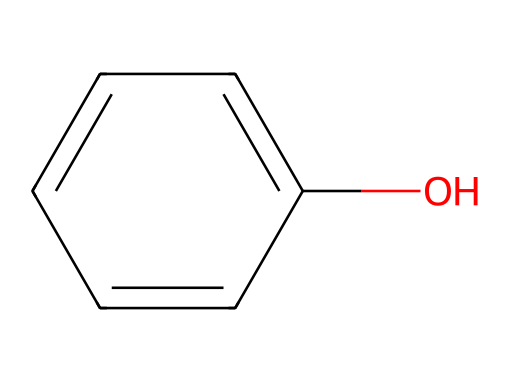How many carbon atoms are present in phenol? In the SMILES representation, "c1ccccc1O" indicates a benzene ring (represented by 'c') with one hydroxyl group 'O' attached. The benzene ring consists of six carbon atoms.
Answer: six What is the functional group in phenol? The presence of the -OH group, which is bonded to a carbon atom in the benzene ring, indicates it is a hydroxyl functional group.
Answer: hydroxyl How many hydrogen atoms are in phenol? The phenolic structure contributes five hydrogen atoms (one is replaced by the -OH group). Counting the hydrogens directly from the structure gives a total of five.
Answer: five What type of bond connects the hydroxyl group to the benzene ring? The hydroxyl group (-OH) is connected to the benzene ring by a single covalent bond. This bond allows for the -OH to contribute to the molecular character of phenol.
Answer: single bond What type of compound is phenol? Given its structure containing a hydroxyl group attached to a benzene ring, phenol falls under the category of aromatic compounds due to resonance and electron delocalization.
Answer: aromatic What physical property is affected by the hydroxyl group in phenol? The presence of the hydroxyl group in phenol affects its polarity, increasing its solubility in water compared to other hydrocarbons without such a group.
Answer: solubility What is the hybridization of the carbon atoms in phenol's benzene ring? Each carbon in the benzene ring undergoes sp2 hybridization, which results in a planar structure with angles of approximately 120 degrees between bonds.
Answer: sp2 